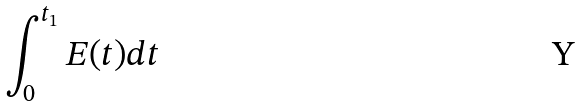Convert formula to latex. <formula><loc_0><loc_0><loc_500><loc_500>\int _ { 0 } ^ { t _ { 1 } } E ( t ) d t</formula> 